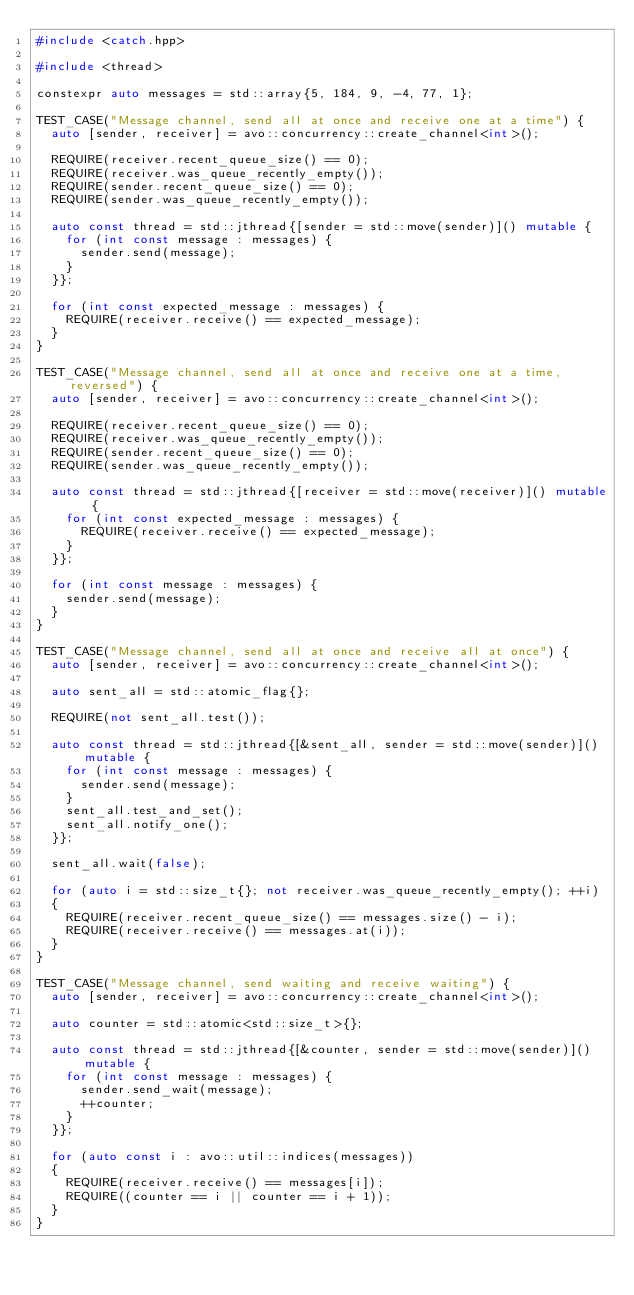<code> <loc_0><loc_0><loc_500><loc_500><_C++_>#include <catch.hpp>

#include <thread>

constexpr auto messages = std::array{5, 184, 9, -4, 77, 1};

TEST_CASE("Message channel, send all at once and receive one at a time") {
	auto [sender, receiver] = avo::concurrency::create_channel<int>();

	REQUIRE(receiver.recent_queue_size() == 0);
	REQUIRE(receiver.was_queue_recently_empty());
	REQUIRE(sender.recent_queue_size() == 0);
	REQUIRE(sender.was_queue_recently_empty());

	auto const thread = std::jthread{[sender = std::move(sender)]() mutable {
		for (int const message : messages) {
			sender.send(message);
		}
	}};

	for (int const expected_message : messages) {
		REQUIRE(receiver.receive() == expected_message);
	}
}

TEST_CASE("Message channel, send all at once and receive one at a time, reversed") {
	auto [sender, receiver] = avo::concurrency::create_channel<int>();

	REQUIRE(receiver.recent_queue_size() == 0);
	REQUIRE(receiver.was_queue_recently_empty());
	REQUIRE(sender.recent_queue_size() == 0);
	REQUIRE(sender.was_queue_recently_empty());

	auto const thread = std::jthread{[receiver = std::move(receiver)]() mutable {
		for (int const expected_message : messages) {
			REQUIRE(receiver.receive() == expected_message);
		}
	}};

	for (int const message : messages) {
		sender.send(message);
	}
}

TEST_CASE("Message channel, send all at once and receive all at once") {
	auto [sender, receiver] = avo::concurrency::create_channel<int>();

	auto sent_all = std::atomic_flag{};

	REQUIRE(not sent_all.test());
	
	auto const thread = std::jthread{[&sent_all, sender = std::move(sender)]() mutable {
		for (int const message : messages) {
			sender.send(message);
		}
		sent_all.test_and_set();
		sent_all.notify_one();
	}};

	sent_all.wait(false);

	for (auto i = std::size_t{}; not receiver.was_queue_recently_empty(); ++i) 
	{
		REQUIRE(receiver.recent_queue_size() == messages.size() - i);
		REQUIRE(receiver.receive() == messages.at(i));
	}
}

TEST_CASE("Message channel, send waiting and receive waiting") {
	auto [sender, receiver] = avo::concurrency::create_channel<int>();

	auto counter = std::atomic<std::size_t>{};

	auto const thread = std::jthread{[&counter, sender = std::move(sender)]() mutable {
		for (int const message : messages) {
			sender.send_wait(message);
			++counter;
		}
	}};

	for (auto const i : avo::util::indices(messages))
	{
		REQUIRE(receiver.receive() == messages[i]);
		REQUIRE((counter == i || counter == i + 1));
	}
}

</code> 